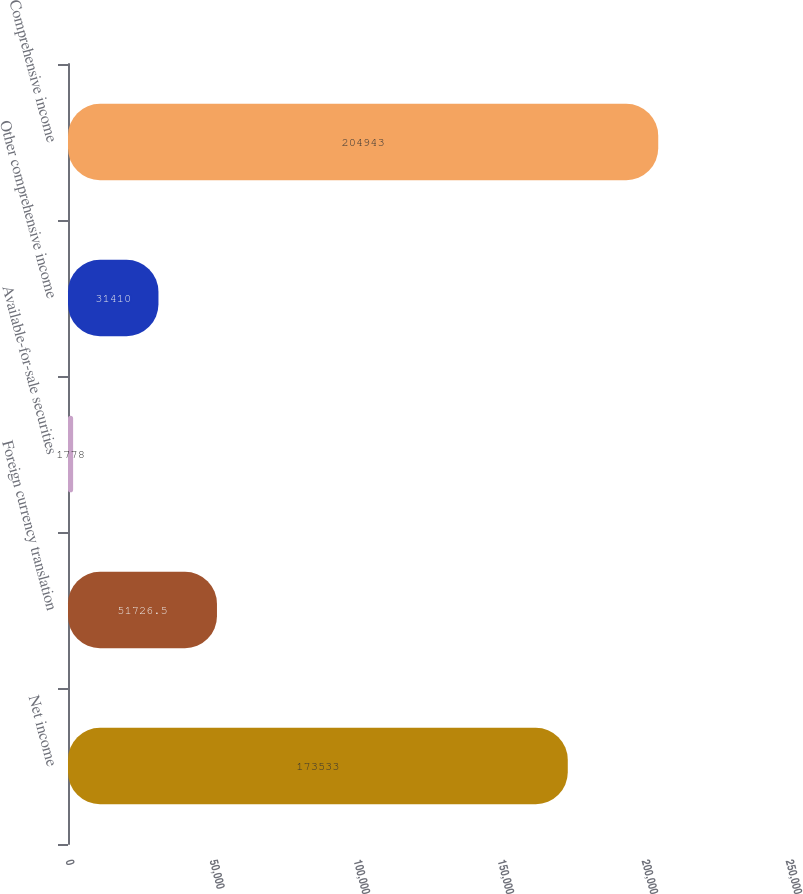<chart> <loc_0><loc_0><loc_500><loc_500><bar_chart><fcel>Net income<fcel>Foreign currency translation<fcel>Available-for-sale securities<fcel>Other comprehensive income<fcel>Comprehensive income<nl><fcel>173533<fcel>51726.5<fcel>1778<fcel>31410<fcel>204943<nl></chart> 